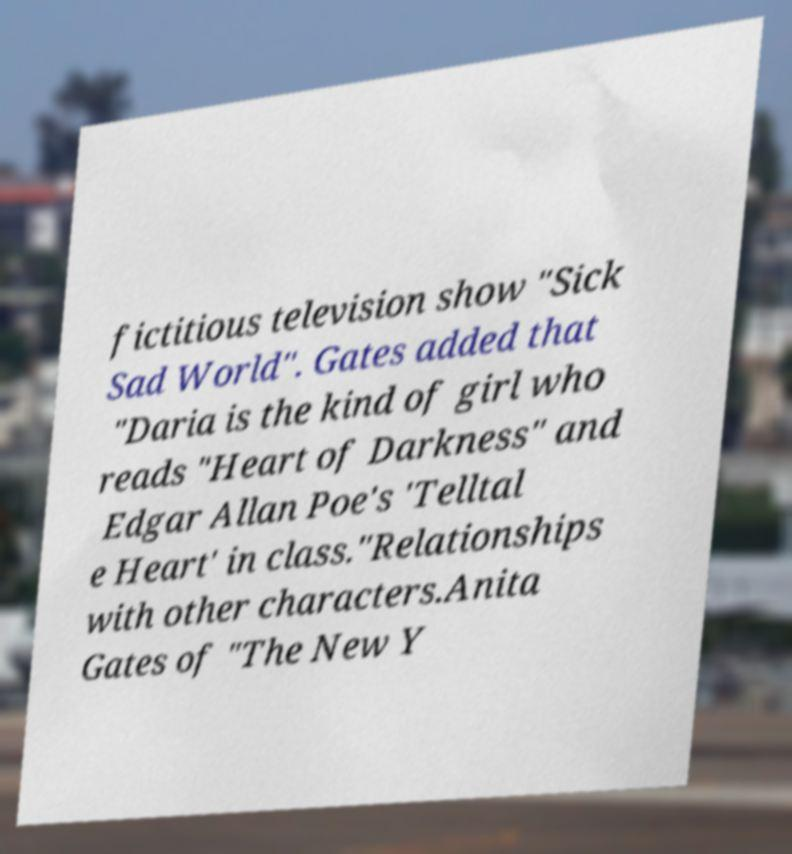Please read and relay the text visible in this image. What does it say? fictitious television show "Sick Sad World". Gates added that "Daria is the kind of girl who reads "Heart of Darkness" and Edgar Allan Poe's 'Telltal e Heart' in class."Relationships with other characters.Anita Gates of "The New Y 